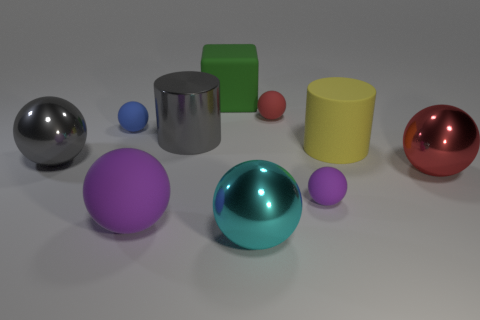Are there fewer blue matte objects in front of the big rubber ball than small yellow metal things?
Keep it short and to the point. No. Is the size of the metal ball that is right of the yellow rubber object the same as the red rubber ball?
Offer a very short reply. No. How many metal spheres are left of the red shiny object and in front of the gray shiny sphere?
Make the answer very short. 1. There is a gray metal object that is to the right of the big shiny ball on the left side of the gray cylinder; how big is it?
Provide a short and direct response. Large. Is the number of purple balls that are behind the large shiny cylinder less than the number of big green rubber cubes that are to the left of the green thing?
Keep it short and to the point. No. Does the tiny matte thing that is left of the tiny red rubber thing have the same color as the metallic ball behind the red metallic object?
Make the answer very short. No. What is the material of the big sphere that is both to the right of the tiny blue thing and on the left side of the gray metallic cylinder?
Your answer should be very brief. Rubber. Is there a large green rubber sphere?
Your answer should be very brief. No. There is a small purple thing that is the same material as the small blue sphere; what shape is it?
Your response must be concise. Sphere. Do the red shiny thing and the tiny object left of the large cyan thing have the same shape?
Offer a very short reply. Yes. 